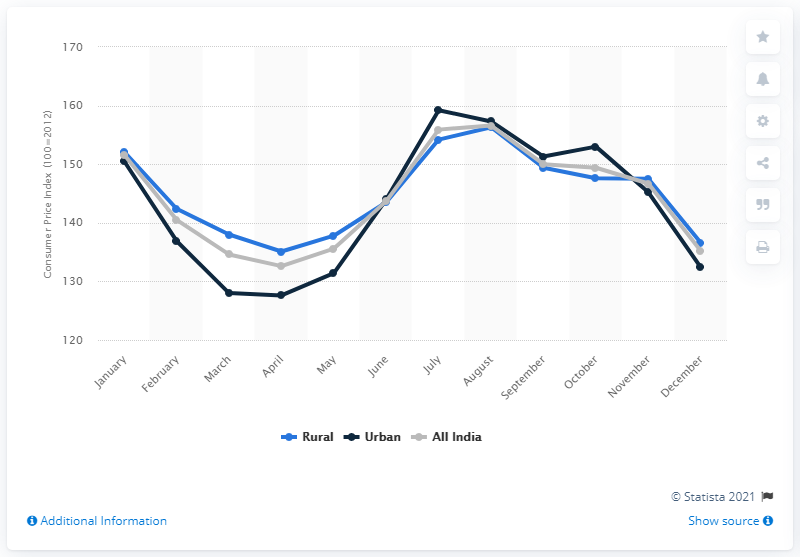Mention a couple of crucial points in this snapshot. The Consumer Price Index for vegetables across urban areas in India in December 2018 was 132.4. 